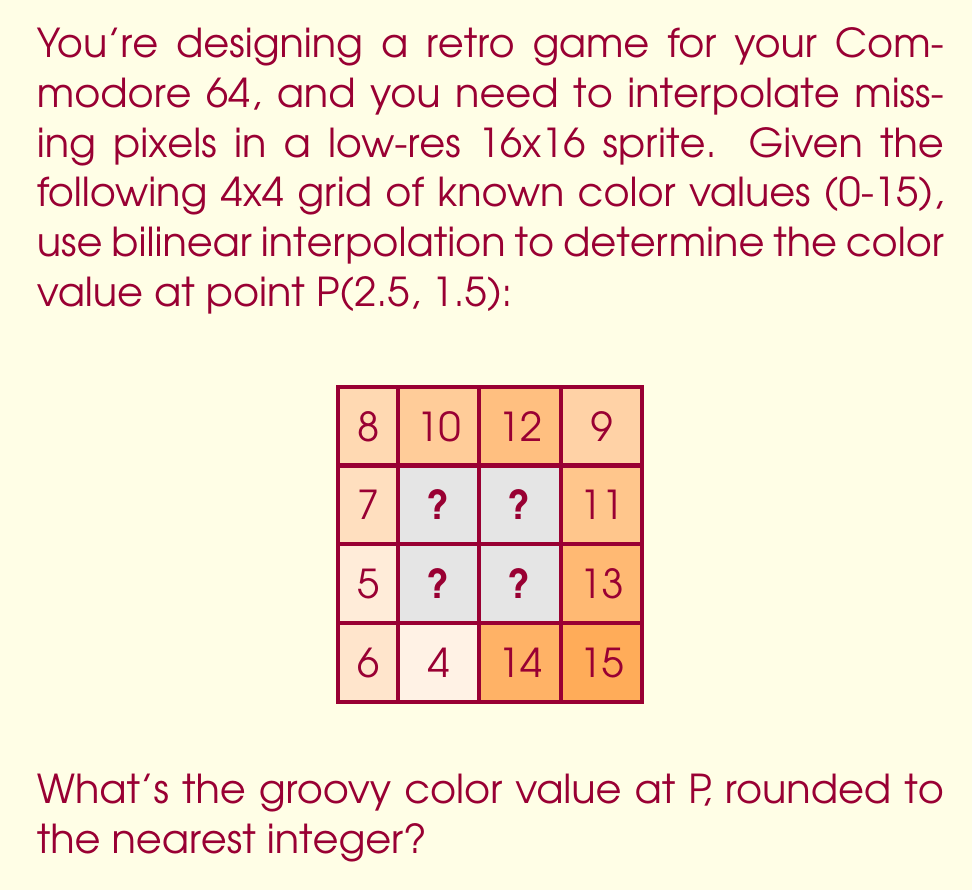Help me with this question. Totally rad! Let's break this down step-by-step:

1) Bilinear interpolation uses the four surrounding points. For P(2.5, 1.5), these are:
   Q11(2,1) = unknown
   Q21(3,1) = unknown
   Q12(2,2) = unknown
   Q22(3,2) = unknown

2) We need to find these unknown values first using linear interpolation:

   For Q11(2,1):
   $Q11 = 10 + (12-10) * (2-2)/(3-2) = 10$

   For Q21(3,1):
   $Q21 = 10 + (12-10) * (3-2)/(3-2) = 12$

   For Q12(2,2):
   $Q12 = 7 + (11-7) * (2-1)/(3-1) = 9$

   For Q22(3,2):
   $Q22 = 7 + (11-7) * (3-1)/(3-1) = 11$

3) Now we can use the bilinear interpolation formula:

   $f(x,y) = f(Q11)(1-t)(1-u) + f(Q21)t(1-u) + f(Q12)(1-t)u + f(Q22)tu$

   Where $t = x - x1 = 2.5 - 2 = 0.5$
   and $u = y - y1 = 1.5 - 1 = 0.5$

4) Plugging in the values:

   $f(2.5,1.5) = 10(1-0.5)(1-0.5) + 12(0.5)(1-0.5) + 9(1-0.5)(0.5) + 11(0.5)(0.5)$

5) Calculating:

   $f(2.5,1.5) = 10(0.25) + 12(0.25) + 9(0.25) + 11(0.25)$
   $f(2.5,1.5) = 2.5 + 3 + 2.25 + 2.75$
   $f(2.5,1.5) = 10.5$

6) Rounding to the nearest integer:

   $10.5 \approx 11$
Answer: 11 